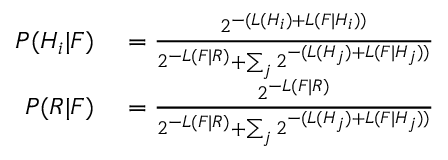Convert formula to latex. <formula><loc_0><loc_0><loc_500><loc_500>\begin{array} { r l } { P ( H _ { i } | F ) } & = { \frac { 2 ^ { - ( L ( H _ { i } ) + L ( F | H _ { i } ) ) } } { 2 ^ { - L ( F | R ) } + \sum _ { j } 2 ^ { - ( L ( H _ { j } ) + L ( F | H _ { j } ) ) } } } } \\ { P ( R | F ) } & = { \frac { 2 ^ { - L ( F | R ) } } { 2 ^ { - L ( F | R ) } + \sum _ { j } { 2 ^ { - ( L ( H _ { j } ) + L ( F | H _ { j } ) ) } } } } } \end{array}</formula> 